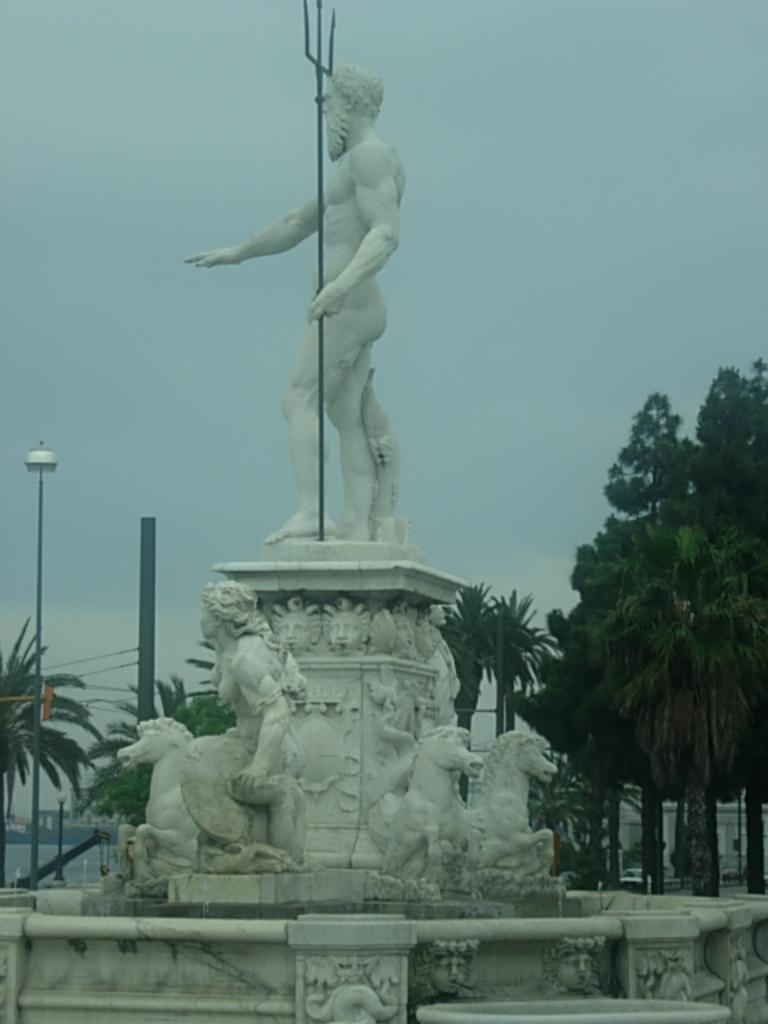Could you give a brief overview of what you see in this image? In this image there is sculpture. There are trees. There is wall. There is sky. 